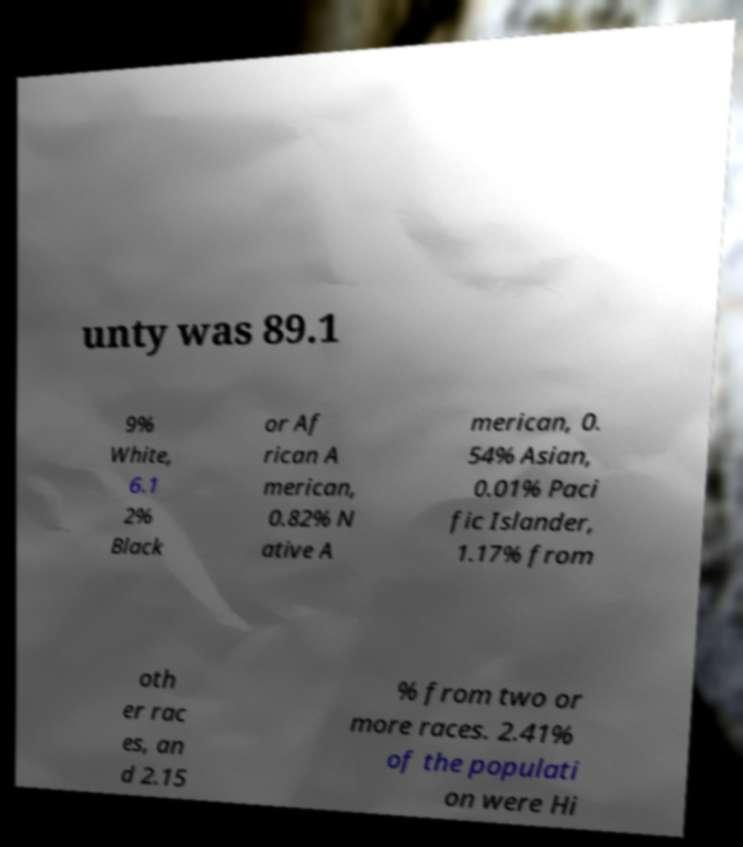Can you read and provide the text displayed in the image?This photo seems to have some interesting text. Can you extract and type it out for me? unty was 89.1 9% White, 6.1 2% Black or Af rican A merican, 0.82% N ative A merican, 0. 54% Asian, 0.01% Paci fic Islander, 1.17% from oth er rac es, an d 2.15 % from two or more races. 2.41% of the populati on were Hi 